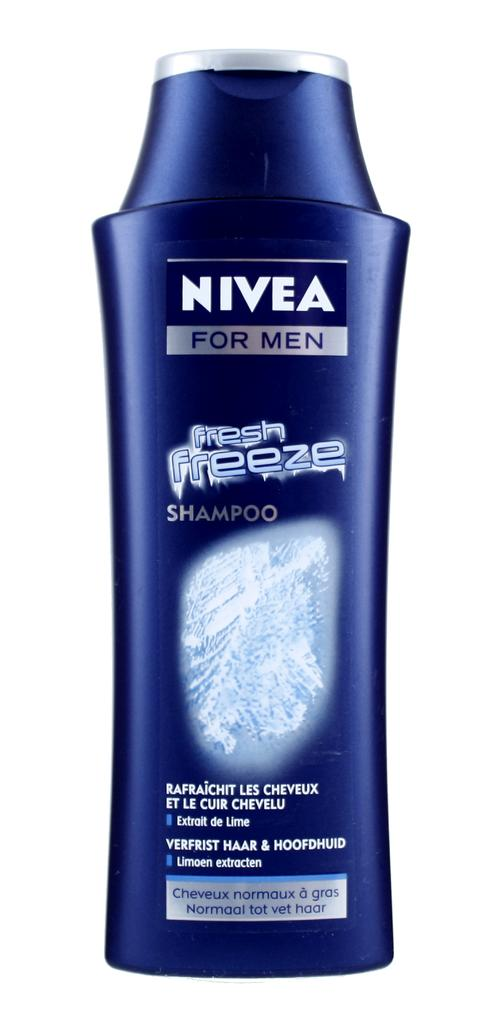Provide a one-sentence caption for the provided image. A bottle of Nivea for men Fresh Freeze shampoo. 